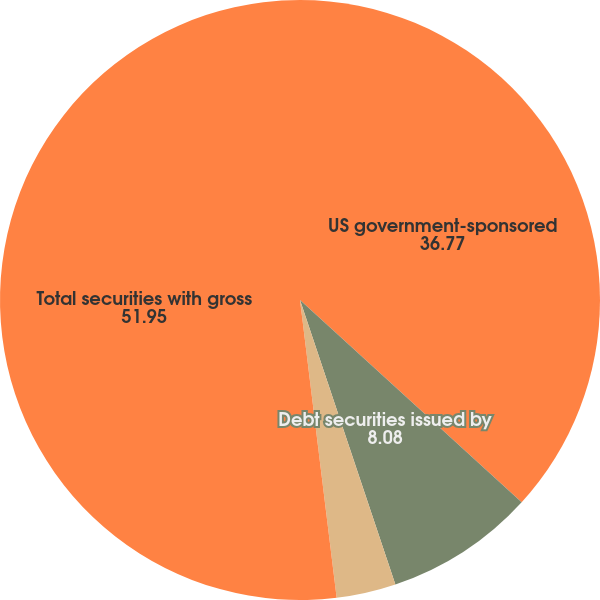Convert chart to OTSL. <chart><loc_0><loc_0><loc_500><loc_500><pie_chart><fcel>US government-sponsored<fcel>Debt securities issued by<fcel>Other primarily asset-backed<fcel>Total securities with gross<nl><fcel>36.77%<fcel>8.08%<fcel>3.2%<fcel>51.95%<nl></chart> 